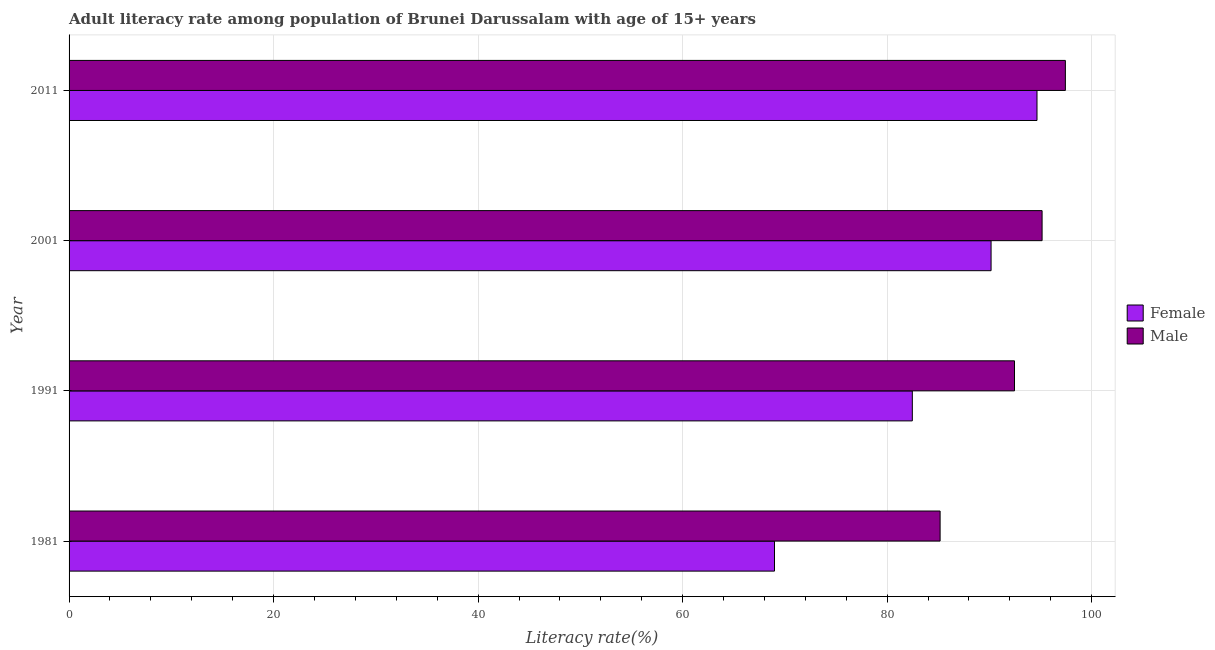What is the label of the 3rd group of bars from the top?
Make the answer very short. 1991. In how many cases, is the number of bars for a given year not equal to the number of legend labels?
Your answer should be compact. 0. What is the male adult literacy rate in 1981?
Your response must be concise. 85.18. Across all years, what is the maximum female adult literacy rate?
Give a very brief answer. 94.65. Across all years, what is the minimum male adult literacy rate?
Make the answer very short. 85.18. In which year was the female adult literacy rate maximum?
Provide a short and direct response. 2011. In which year was the female adult literacy rate minimum?
Your response must be concise. 1981. What is the total female adult literacy rate in the graph?
Offer a very short reply. 336.26. What is the difference between the male adult literacy rate in 1981 and that in 1991?
Your response must be concise. -7.27. What is the difference between the male adult literacy rate in 1981 and the female adult literacy rate in 2001?
Your response must be concise. -4.98. What is the average female adult literacy rate per year?
Keep it short and to the point. 84.06. In the year 1991, what is the difference between the female adult literacy rate and male adult literacy rate?
Make the answer very short. -9.99. In how many years, is the male adult literacy rate greater than 52 %?
Provide a succinct answer. 4. What is the ratio of the male adult literacy rate in 1981 to that in 2011?
Your answer should be very brief. 0.87. Is the difference between the female adult literacy rate in 2001 and 2011 greater than the difference between the male adult literacy rate in 2001 and 2011?
Provide a short and direct response. No. What is the difference between the highest and the second highest male adult literacy rate?
Your answer should be compact. 2.28. What is the difference between the highest and the lowest female adult literacy rate?
Your response must be concise. 25.67. In how many years, is the male adult literacy rate greater than the average male adult literacy rate taken over all years?
Your answer should be very brief. 2. What does the 1st bar from the top in 2011 represents?
Your answer should be compact. Male. Are all the bars in the graph horizontal?
Your answer should be very brief. Yes. How many years are there in the graph?
Keep it short and to the point. 4. Are the values on the major ticks of X-axis written in scientific E-notation?
Ensure brevity in your answer.  No. Does the graph contain any zero values?
Provide a succinct answer. No. Does the graph contain grids?
Provide a succinct answer. Yes. What is the title of the graph?
Make the answer very short. Adult literacy rate among population of Brunei Darussalam with age of 15+ years. Does "Nitrous oxide" appear as one of the legend labels in the graph?
Ensure brevity in your answer.  No. What is the label or title of the X-axis?
Offer a terse response. Literacy rate(%). What is the label or title of the Y-axis?
Ensure brevity in your answer.  Year. What is the Literacy rate(%) of Female in 1981?
Keep it short and to the point. 68.98. What is the Literacy rate(%) in Male in 1981?
Give a very brief answer. 85.18. What is the Literacy rate(%) in Female in 1991?
Your answer should be compact. 82.46. What is the Literacy rate(%) of Male in 1991?
Provide a short and direct response. 92.45. What is the Literacy rate(%) in Female in 2001?
Make the answer very short. 90.16. What is the Literacy rate(%) in Male in 2001?
Offer a terse response. 95.15. What is the Literacy rate(%) of Female in 2011?
Give a very brief answer. 94.65. What is the Literacy rate(%) in Male in 2011?
Ensure brevity in your answer.  97.43. Across all years, what is the maximum Literacy rate(%) of Female?
Give a very brief answer. 94.65. Across all years, what is the maximum Literacy rate(%) of Male?
Provide a short and direct response. 97.43. Across all years, what is the minimum Literacy rate(%) of Female?
Offer a terse response. 68.98. Across all years, what is the minimum Literacy rate(%) of Male?
Offer a very short reply. 85.18. What is the total Literacy rate(%) of Female in the graph?
Offer a very short reply. 336.26. What is the total Literacy rate(%) of Male in the graph?
Your answer should be very brief. 370.21. What is the difference between the Literacy rate(%) in Female in 1981 and that in 1991?
Provide a short and direct response. -13.48. What is the difference between the Literacy rate(%) of Male in 1981 and that in 1991?
Provide a succinct answer. -7.27. What is the difference between the Literacy rate(%) of Female in 1981 and that in 2001?
Give a very brief answer. -21.18. What is the difference between the Literacy rate(%) in Male in 1981 and that in 2001?
Ensure brevity in your answer.  -9.97. What is the difference between the Literacy rate(%) in Female in 1981 and that in 2011?
Ensure brevity in your answer.  -25.67. What is the difference between the Literacy rate(%) in Male in 1981 and that in 2011?
Your answer should be very brief. -12.25. What is the difference between the Literacy rate(%) in Female in 1991 and that in 2001?
Offer a terse response. -7.7. What is the difference between the Literacy rate(%) of Male in 1991 and that in 2001?
Make the answer very short. -2.7. What is the difference between the Literacy rate(%) in Female in 1991 and that in 2011?
Keep it short and to the point. -12.19. What is the difference between the Literacy rate(%) of Male in 1991 and that in 2011?
Ensure brevity in your answer.  -4.98. What is the difference between the Literacy rate(%) of Female in 2001 and that in 2011?
Offer a terse response. -4.49. What is the difference between the Literacy rate(%) in Male in 2001 and that in 2011?
Keep it short and to the point. -2.28. What is the difference between the Literacy rate(%) of Female in 1981 and the Literacy rate(%) of Male in 1991?
Ensure brevity in your answer.  -23.47. What is the difference between the Literacy rate(%) in Female in 1981 and the Literacy rate(%) in Male in 2001?
Offer a very short reply. -26.17. What is the difference between the Literacy rate(%) in Female in 1981 and the Literacy rate(%) in Male in 2011?
Ensure brevity in your answer.  -28.45. What is the difference between the Literacy rate(%) of Female in 1991 and the Literacy rate(%) of Male in 2001?
Your answer should be compact. -12.69. What is the difference between the Literacy rate(%) of Female in 1991 and the Literacy rate(%) of Male in 2011?
Offer a terse response. -14.97. What is the difference between the Literacy rate(%) of Female in 2001 and the Literacy rate(%) of Male in 2011?
Your response must be concise. -7.27. What is the average Literacy rate(%) in Female per year?
Your answer should be very brief. 84.06. What is the average Literacy rate(%) in Male per year?
Provide a short and direct response. 92.55. In the year 1981, what is the difference between the Literacy rate(%) in Female and Literacy rate(%) in Male?
Your answer should be compact. -16.2. In the year 1991, what is the difference between the Literacy rate(%) of Female and Literacy rate(%) of Male?
Your response must be concise. -9.99. In the year 2001, what is the difference between the Literacy rate(%) of Female and Literacy rate(%) of Male?
Your response must be concise. -4.99. In the year 2011, what is the difference between the Literacy rate(%) of Female and Literacy rate(%) of Male?
Offer a terse response. -2.78. What is the ratio of the Literacy rate(%) of Female in 1981 to that in 1991?
Offer a terse response. 0.84. What is the ratio of the Literacy rate(%) in Male in 1981 to that in 1991?
Offer a terse response. 0.92. What is the ratio of the Literacy rate(%) of Female in 1981 to that in 2001?
Keep it short and to the point. 0.77. What is the ratio of the Literacy rate(%) of Male in 1981 to that in 2001?
Ensure brevity in your answer.  0.9. What is the ratio of the Literacy rate(%) in Female in 1981 to that in 2011?
Your response must be concise. 0.73. What is the ratio of the Literacy rate(%) in Male in 1981 to that in 2011?
Give a very brief answer. 0.87. What is the ratio of the Literacy rate(%) of Female in 1991 to that in 2001?
Offer a very short reply. 0.91. What is the ratio of the Literacy rate(%) in Male in 1991 to that in 2001?
Keep it short and to the point. 0.97. What is the ratio of the Literacy rate(%) of Female in 1991 to that in 2011?
Provide a succinct answer. 0.87. What is the ratio of the Literacy rate(%) in Male in 1991 to that in 2011?
Keep it short and to the point. 0.95. What is the ratio of the Literacy rate(%) of Female in 2001 to that in 2011?
Offer a terse response. 0.95. What is the ratio of the Literacy rate(%) of Male in 2001 to that in 2011?
Make the answer very short. 0.98. What is the difference between the highest and the second highest Literacy rate(%) in Female?
Offer a terse response. 4.49. What is the difference between the highest and the second highest Literacy rate(%) of Male?
Your answer should be compact. 2.28. What is the difference between the highest and the lowest Literacy rate(%) of Female?
Your answer should be very brief. 25.67. What is the difference between the highest and the lowest Literacy rate(%) in Male?
Your response must be concise. 12.25. 